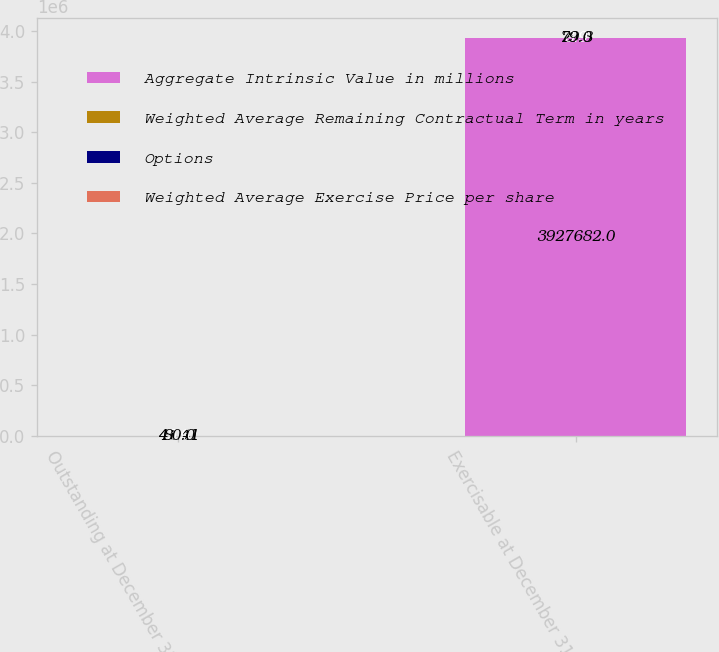Convert chart to OTSL. <chart><loc_0><loc_0><loc_500><loc_500><stacked_bar_chart><ecel><fcel>Outstanding at December 31<fcel>Exercisable at December 31<nl><fcel>Aggregate Intrinsic Value in millions<fcel>41.41<fcel>3.92768e+06<nl><fcel>Weighted Average Remaining Contractual Term in years<fcel>41.41<fcel>29.8<nl><fcel>Options<fcel>5.6<fcel>3.9<nl><fcel>Weighted Average Exercise Price per share<fcel>80<fcel>79<nl></chart> 